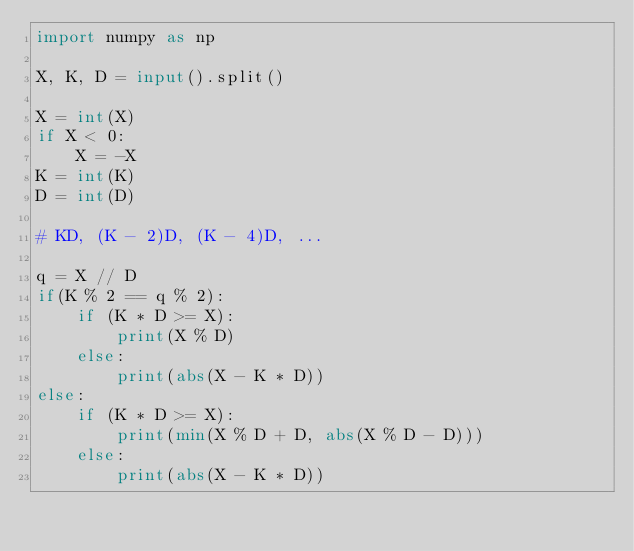Convert code to text. <code><loc_0><loc_0><loc_500><loc_500><_Python_>import numpy as np

X, K, D = input().split()

X = int(X)
if X < 0:
    X = -X
K = int(K)
D = int(D)

# KD, (K - 2)D, (K - 4)D, ...

q = X // D
if(K % 2 == q % 2):
    if (K * D >= X):
        print(X % D)
    else:
        print(abs(X - K * D))
else:
    if (K * D >= X):
        print(min(X % D + D, abs(X % D - D)))
    else:
        print(abs(X - K * D))
</code> 